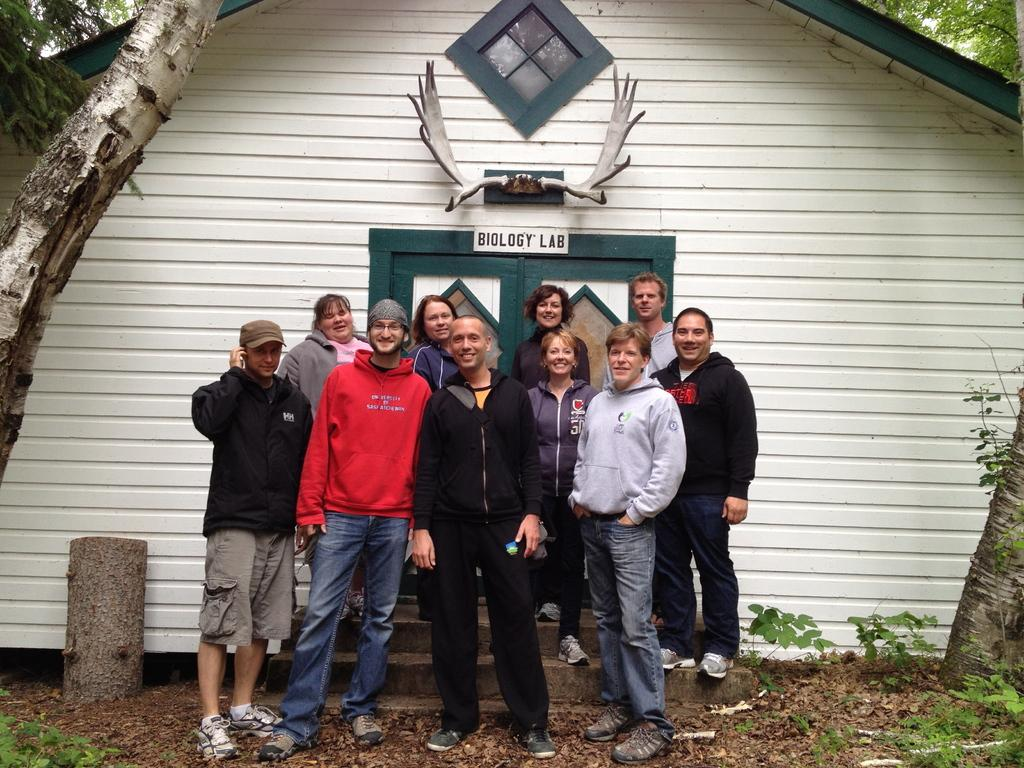How many people are in the image? There is a group of people in the image. Where are the people standing in the image? The people are standing on the ground and steps. What is the facial expression of the people in the image? The people are smiling. What can be seen in the background of the image? There is a house and trees in the background of the image. What features does the house have? The house has doors. How many dimes are scattered on the ground in the image? There are no dimes visible in the image; it features a group of people standing on the ground and steps. What type of drum can be heard playing in the background of the image? There is no drum or any sound present in the image; it only shows a group of people standing and smiling. 